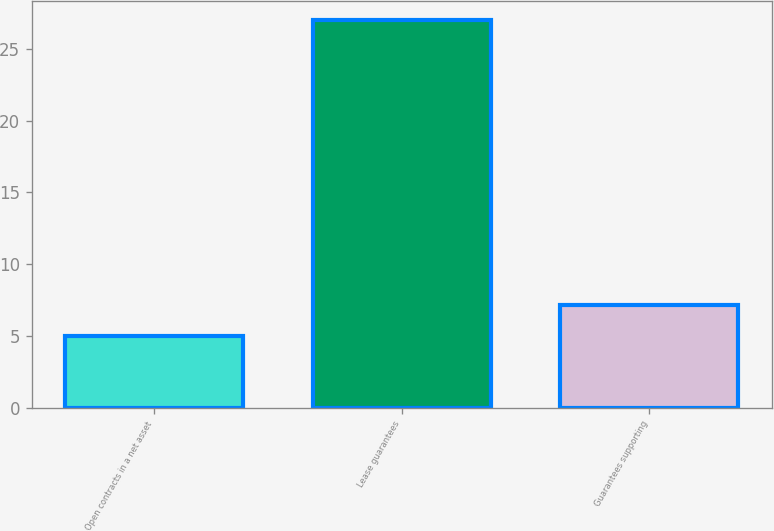Convert chart to OTSL. <chart><loc_0><loc_0><loc_500><loc_500><bar_chart><fcel>Open contracts in a net asset<fcel>Lease guarantees<fcel>Guarantees supporting<nl><fcel>5<fcel>27<fcel>7.2<nl></chart> 